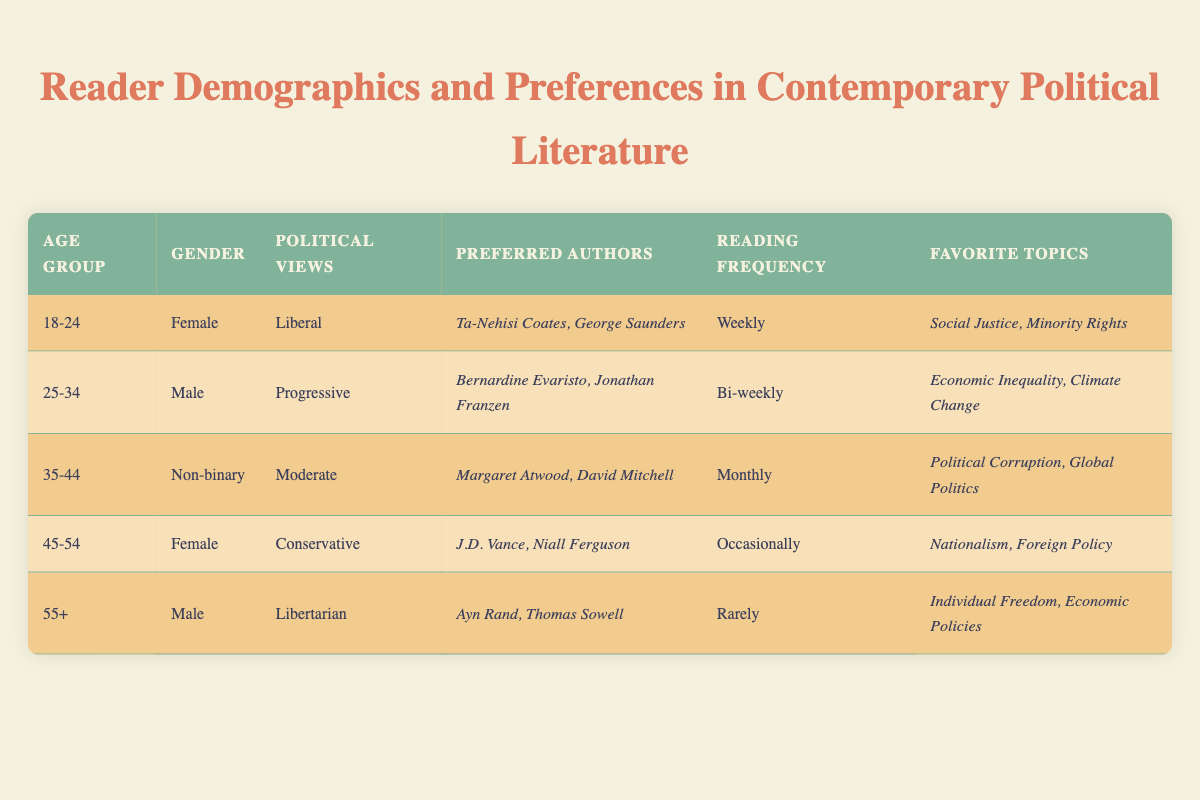What is the preferred reading frequency for the 18-24 age group? According to the table, the 18-24 age group reads "Weekly."
Answer: Weekly How many preferred authors does the 45-54 age group have? The 45-54 age group has two preferred authors: J.D. Vance and Niall Ferguson.
Answer: 2 Is there a non-binary reader in the table? Yes, the 35-44 age group is represented by a non-binary reader.
Answer: Yes Which age group prefers authors associated with "Social Justice"? The 18-24 age group prefers authors associated with "Social Justice," specifically Ta-Nehisi Coates and George Saunders.
Answer: 18-24 What are the favorite topics of the 25-34 age group? The favorite topics from the 25-34 age group are "Economic Inequality" and "Climate Change."
Answer: Economic Inequality, Climate Change Which political view is represented by the female reader in the 45-54 age group? The female reader in the 45-54 age group holds Conservative political views.
Answer: Conservative What is the reading frequency for the group that prefers Ayn Rand and Thomas Sowell? The 55+ age group that prefers Ayn Rand and Thomas Sowell reads "Rarely."
Answer: Rarely Which age group has the highest reading frequency? The 18-24 age group has the highest reading frequency at "Weekly." The 25-34 age group follows with "Bi-weekly."
Answer: 18-24 Are there any authors preferred by both the 55+ age group and the 25-34 age group? No, the authors preferred by the 55+ age group (Ayn Rand and Thomas Sowell) differ from those of the 25-34 age group (Bernardine Evaristo and Jonathan Franzen).
Answer: No What is the average reading frequency of the age groups? The reading frequencies are: Weekly (1), Bi-weekly (0.5), Monthly (0.33), Occasionally (0.25), and Rarely (0.14). To find the average: (1 + 0.5 + 0.33 + 0.25 + 0.14) / 5 = 0.644, which is approximately "Every 1.55 weeks" when translated back to a frequency format.
Answer: Every 1.55 weeks 